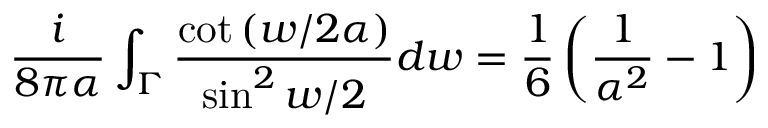<formula> <loc_0><loc_0><loc_500><loc_500>{ \frac { i } { 8 \pi \alpha } } \int _ { \Gamma } { \frac { \cot \left ( { w / 2 \alpha } \right ) } { \sin ^ { 2 } w / 2 } } d w = \frac { 1 } { 6 } \left ( { \frac { 1 } { \alpha ^ { 2 } } } - 1 \right )</formula> 